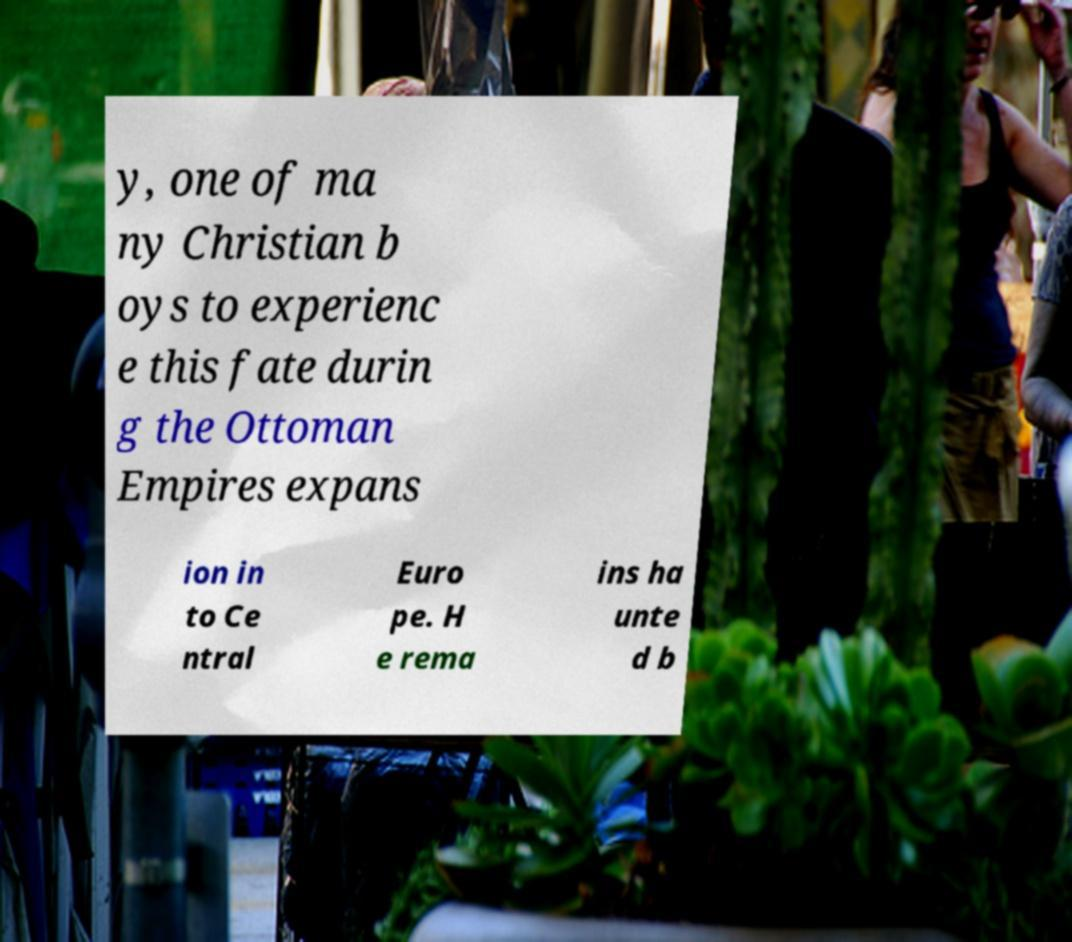Can you accurately transcribe the text from the provided image for me? y, one of ma ny Christian b oys to experienc e this fate durin g the Ottoman Empires expans ion in to Ce ntral Euro pe. H e rema ins ha unte d b 